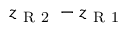Convert formula to latex. <formula><loc_0><loc_0><loc_500><loc_500>z _ { R 2 } - z _ { R 1 }</formula> 